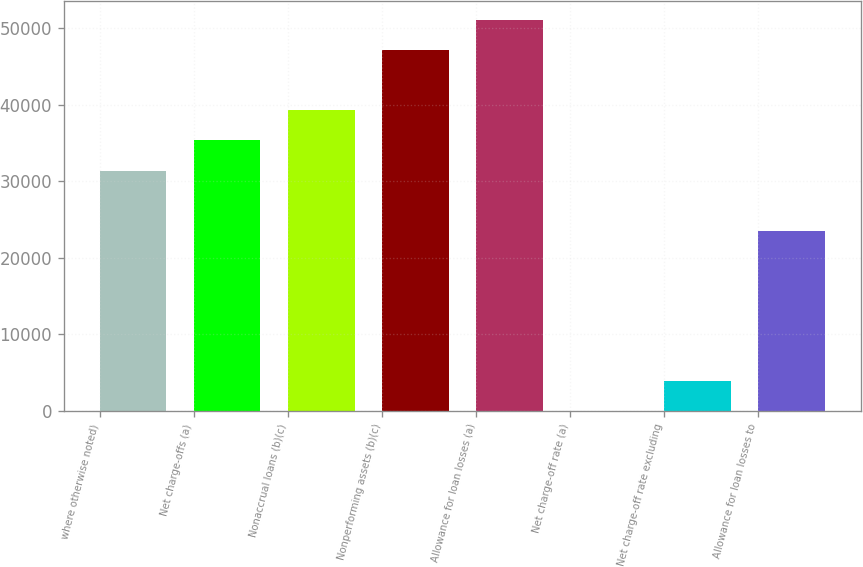<chart> <loc_0><loc_0><loc_500><loc_500><bar_chart><fcel>where otherwise noted)<fcel>Net charge-offs (a)<fcel>Nonaccrual loans (b)(c)<fcel>Nonperforming assets (b)(c)<fcel>Allowance for loan losses (a)<fcel>Net charge-off rate (a)<fcel>Net charge-off rate excluding<fcel>Allowance for loan losses to<nl><fcel>31393.8<fcel>35317.9<fcel>39242<fcel>47090.2<fcel>51014.3<fcel>0.99<fcel>3925.09<fcel>23545.6<nl></chart> 